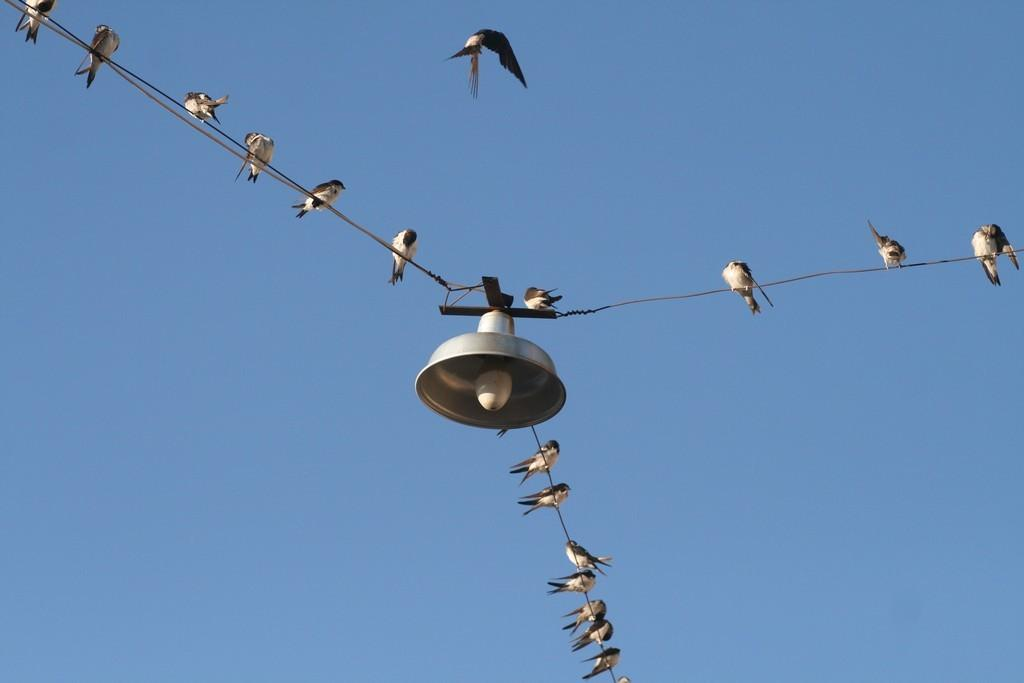What can be seen on the wires in the image? There are birds on the wires in the image. What object is present in the image that provides light? There is a bulb in the image. What type of structure is visible in the image? There is a dome in the image. What is the bird in the top part of the image doing? A bird is flying in the air in the top part of the image. Where is the pail located in the image? There is no pail present in the image. Can you see any goldfish swimming in the image? There are no goldfish present in the image. 